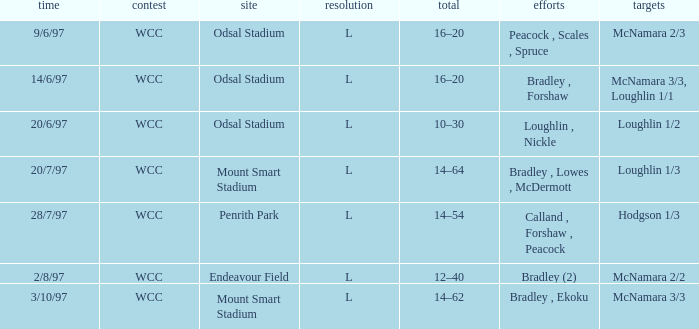What was the score on 20/6/97? 10–30. 